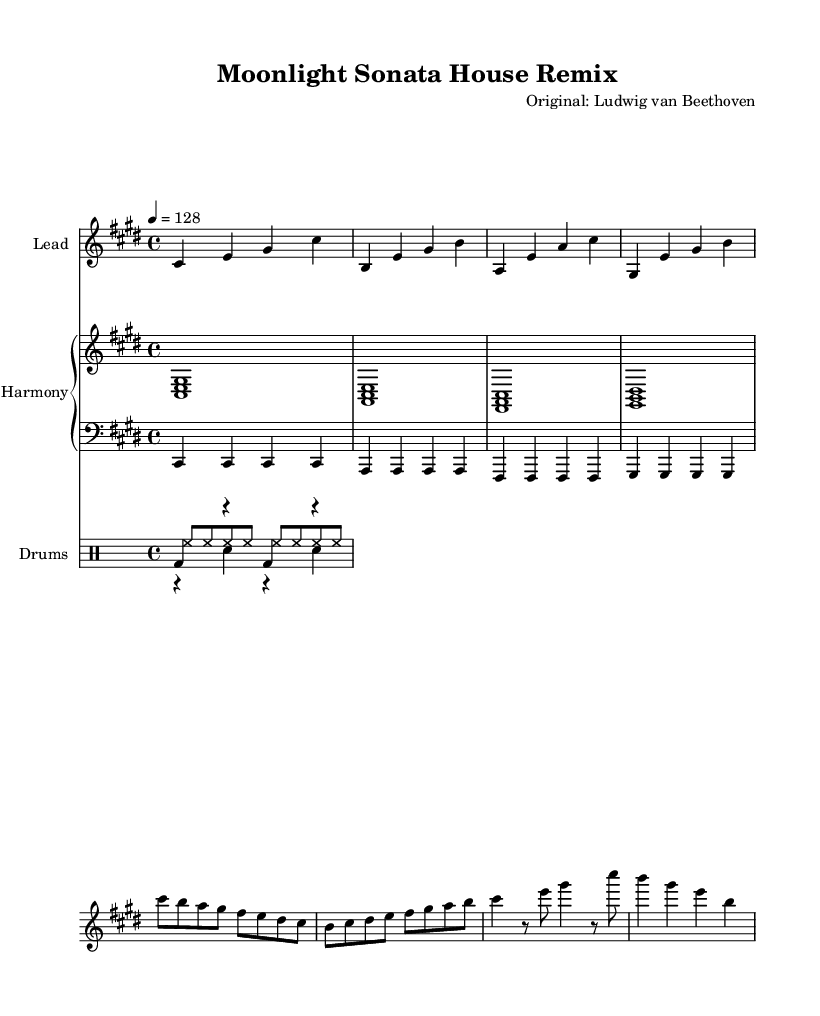What is the key signature of this music? The key signature is indicated at the beginning of the score, showing three sharps, which indicates the piece is in C sharp minor.
Answer: C sharp minor What is the time signature of the piece? The time signature appears at the beginning of the score, showing a four over four, meaning there are four beats in each measure.
Answer: Four over four What is the tempo marking of this piece? The tempo marking is found at the start of the score, indicating a speed of 128 beats per minute, which is relatively brisk for a remix.
Answer: 128 How many measures are there in this composition? By counting the individual measures in the melody and harmonic staves, it's determined that there are a total of 8 measures present.
Answer: Eight What is the rhythm pattern of the kick drum in the drum section? The kick drum pattern is outlined in the drum part, indicating a bass drum hit on the beat followed by a rest, repeating in a simple quarter-note structure.
Answer: Quarter-note pattern Describe the overall texture of the piece. Analyzing the sections together, the piece features a polyphonic texture with a lead melody supported by harmonic chords and a rhythmic drum pattern.
Answer: Polyphonic texture What is the function of the bass line in this remix? The bass line provides a foundational support, reinforcing the harmony without diverging from the main harmonic progression, maintaining rhythmic stability throughout.
Answer: Foundation support 